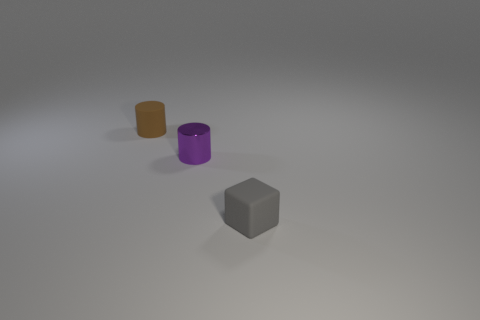Add 1 brown cylinders. How many objects exist? 4 Subtract all blocks. How many objects are left? 2 Add 3 tiny cyan metallic cylinders. How many tiny cyan metallic cylinders exist? 3 Subtract 0 red cylinders. How many objects are left? 3 Subtract all large yellow rubber spheres. Subtract all small rubber cubes. How many objects are left? 2 Add 2 cylinders. How many cylinders are left? 4 